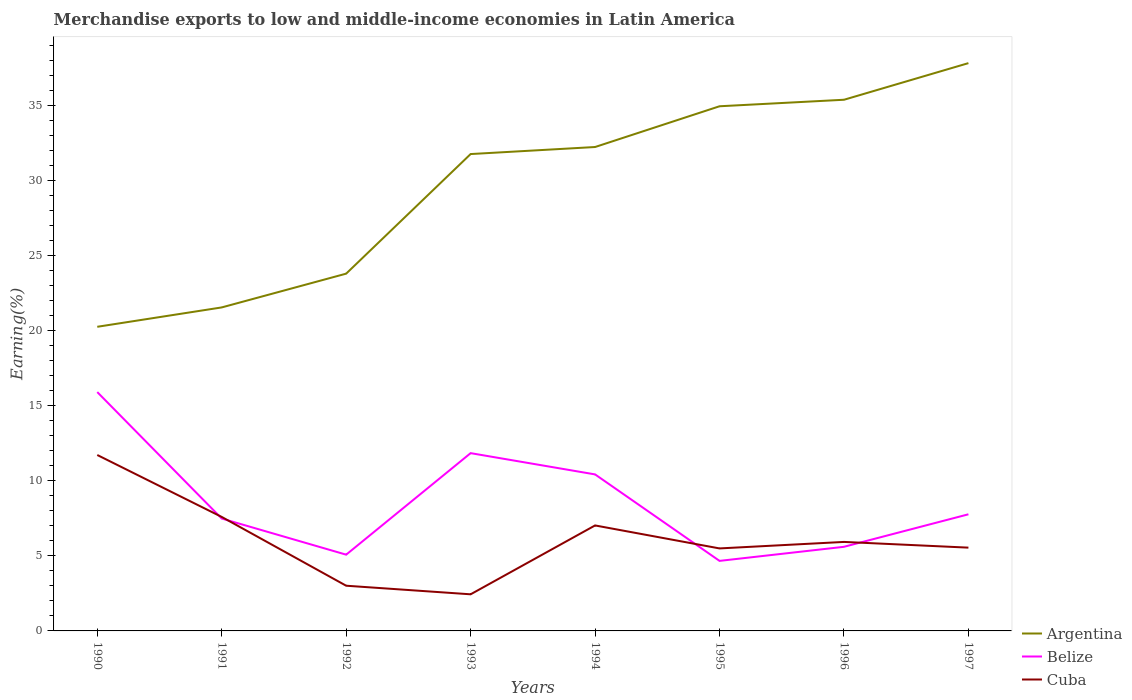Does the line corresponding to Cuba intersect with the line corresponding to Argentina?
Offer a terse response. No. Is the number of lines equal to the number of legend labels?
Give a very brief answer. Yes. Across all years, what is the maximum percentage of amount earned from merchandise exports in Belize?
Ensure brevity in your answer.  4.67. In which year was the percentage of amount earned from merchandise exports in Cuba maximum?
Offer a terse response. 1993. What is the total percentage of amount earned from merchandise exports in Argentina in the graph?
Ensure brevity in your answer.  -13.4. What is the difference between the highest and the second highest percentage of amount earned from merchandise exports in Belize?
Your answer should be very brief. 11.25. How many years are there in the graph?
Your answer should be compact. 8. Does the graph contain grids?
Offer a very short reply. No. How many legend labels are there?
Keep it short and to the point. 3. How are the legend labels stacked?
Provide a short and direct response. Vertical. What is the title of the graph?
Your answer should be compact. Merchandise exports to low and middle-income economies in Latin America. What is the label or title of the X-axis?
Offer a very short reply. Years. What is the label or title of the Y-axis?
Keep it short and to the point. Earning(%). What is the Earning(%) in Argentina in 1990?
Offer a terse response. 20.26. What is the Earning(%) in Belize in 1990?
Offer a terse response. 15.91. What is the Earning(%) in Cuba in 1990?
Give a very brief answer. 11.72. What is the Earning(%) in Argentina in 1991?
Your answer should be very brief. 21.55. What is the Earning(%) in Belize in 1991?
Give a very brief answer. 7.49. What is the Earning(%) in Cuba in 1991?
Your response must be concise. 7.59. What is the Earning(%) of Argentina in 1992?
Your response must be concise. 23.8. What is the Earning(%) in Belize in 1992?
Ensure brevity in your answer.  5.08. What is the Earning(%) in Cuba in 1992?
Your answer should be very brief. 3.01. What is the Earning(%) of Argentina in 1993?
Your response must be concise. 31.77. What is the Earning(%) in Belize in 1993?
Your answer should be very brief. 11.84. What is the Earning(%) in Cuba in 1993?
Make the answer very short. 2.44. What is the Earning(%) in Argentina in 1994?
Give a very brief answer. 32.24. What is the Earning(%) in Belize in 1994?
Provide a succinct answer. 10.43. What is the Earning(%) of Cuba in 1994?
Ensure brevity in your answer.  7.03. What is the Earning(%) of Argentina in 1995?
Provide a short and direct response. 34.96. What is the Earning(%) of Belize in 1995?
Offer a terse response. 4.67. What is the Earning(%) in Cuba in 1995?
Give a very brief answer. 5.5. What is the Earning(%) in Argentina in 1996?
Your answer should be very brief. 35.39. What is the Earning(%) in Belize in 1996?
Make the answer very short. 5.6. What is the Earning(%) of Cuba in 1996?
Make the answer very short. 5.93. What is the Earning(%) of Argentina in 1997?
Provide a succinct answer. 37.83. What is the Earning(%) in Belize in 1997?
Your response must be concise. 7.77. What is the Earning(%) in Cuba in 1997?
Provide a succinct answer. 5.55. Across all years, what is the maximum Earning(%) in Argentina?
Your response must be concise. 37.83. Across all years, what is the maximum Earning(%) of Belize?
Your answer should be very brief. 15.91. Across all years, what is the maximum Earning(%) in Cuba?
Provide a short and direct response. 11.72. Across all years, what is the minimum Earning(%) of Argentina?
Ensure brevity in your answer.  20.26. Across all years, what is the minimum Earning(%) of Belize?
Your answer should be very brief. 4.67. Across all years, what is the minimum Earning(%) of Cuba?
Make the answer very short. 2.44. What is the total Earning(%) of Argentina in the graph?
Make the answer very short. 237.81. What is the total Earning(%) in Belize in the graph?
Offer a terse response. 68.8. What is the total Earning(%) of Cuba in the graph?
Your answer should be very brief. 48.77. What is the difference between the Earning(%) in Argentina in 1990 and that in 1991?
Provide a succinct answer. -1.29. What is the difference between the Earning(%) of Belize in 1990 and that in 1991?
Provide a short and direct response. 8.42. What is the difference between the Earning(%) of Cuba in 1990 and that in 1991?
Make the answer very short. 4.13. What is the difference between the Earning(%) of Argentina in 1990 and that in 1992?
Offer a terse response. -3.54. What is the difference between the Earning(%) of Belize in 1990 and that in 1992?
Offer a very short reply. 10.83. What is the difference between the Earning(%) of Cuba in 1990 and that in 1992?
Offer a very short reply. 8.71. What is the difference between the Earning(%) of Argentina in 1990 and that in 1993?
Make the answer very short. -11.51. What is the difference between the Earning(%) in Belize in 1990 and that in 1993?
Your response must be concise. 4.07. What is the difference between the Earning(%) of Cuba in 1990 and that in 1993?
Offer a terse response. 9.28. What is the difference between the Earning(%) of Argentina in 1990 and that in 1994?
Offer a very short reply. -11.98. What is the difference between the Earning(%) of Belize in 1990 and that in 1994?
Ensure brevity in your answer.  5.48. What is the difference between the Earning(%) in Cuba in 1990 and that in 1994?
Provide a succinct answer. 4.69. What is the difference between the Earning(%) in Argentina in 1990 and that in 1995?
Offer a terse response. -14.69. What is the difference between the Earning(%) in Belize in 1990 and that in 1995?
Your response must be concise. 11.25. What is the difference between the Earning(%) of Cuba in 1990 and that in 1995?
Ensure brevity in your answer.  6.22. What is the difference between the Earning(%) in Argentina in 1990 and that in 1996?
Offer a terse response. -15.13. What is the difference between the Earning(%) in Belize in 1990 and that in 1996?
Offer a very short reply. 10.31. What is the difference between the Earning(%) in Cuba in 1990 and that in 1996?
Keep it short and to the point. 5.79. What is the difference between the Earning(%) of Argentina in 1990 and that in 1997?
Your answer should be compact. -17.57. What is the difference between the Earning(%) in Belize in 1990 and that in 1997?
Make the answer very short. 8.14. What is the difference between the Earning(%) of Cuba in 1990 and that in 1997?
Offer a very short reply. 6.17. What is the difference between the Earning(%) in Argentina in 1991 and that in 1992?
Your answer should be very brief. -2.25. What is the difference between the Earning(%) in Belize in 1991 and that in 1992?
Offer a terse response. 2.41. What is the difference between the Earning(%) of Cuba in 1991 and that in 1992?
Your response must be concise. 4.58. What is the difference between the Earning(%) of Argentina in 1991 and that in 1993?
Make the answer very short. -10.22. What is the difference between the Earning(%) in Belize in 1991 and that in 1993?
Keep it short and to the point. -4.36. What is the difference between the Earning(%) of Cuba in 1991 and that in 1993?
Your answer should be compact. 5.16. What is the difference between the Earning(%) of Argentina in 1991 and that in 1994?
Keep it short and to the point. -10.69. What is the difference between the Earning(%) in Belize in 1991 and that in 1994?
Make the answer very short. -2.94. What is the difference between the Earning(%) in Cuba in 1991 and that in 1994?
Provide a short and direct response. 0.57. What is the difference between the Earning(%) of Argentina in 1991 and that in 1995?
Ensure brevity in your answer.  -13.4. What is the difference between the Earning(%) of Belize in 1991 and that in 1995?
Offer a very short reply. 2.82. What is the difference between the Earning(%) in Cuba in 1991 and that in 1995?
Offer a terse response. 2.1. What is the difference between the Earning(%) of Argentina in 1991 and that in 1996?
Your response must be concise. -13.84. What is the difference between the Earning(%) of Belize in 1991 and that in 1996?
Offer a very short reply. 1.88. What is the difference between the Earning(%) in Cuba in 1991 and that in 1996?
Provide a short and direct response. 1.67. What is the difference between the Earning(%) in Argentina in 1991 and that in 1997?
Make the answer very short. -16.28. What is the difference between the Earning(%) in Belize in 1991 and that in 1997?
Your response must be concise. -0.28. What is the difference between the Earning(%) in Cuba in 1991 and that in 1997?
Your answer should be very brief. 2.05. What is the difference between the Earning(%) in Argentina in 1992 and that in 1993?
Ensure brevity in your answer.  -7.97. What is the difference between the Earning(%) of Belize in 1992 and that in 1993?
Ensure brevity in your answer.  -6.76. What is the difference between the Earning(%) in Cuba in 1992 and that in 1993?
Your answer should be compact. 0.57. What is the difference between the Earning(%) of Argentina in 1992 and that in 1994?
Provide a short and direct response. -8.44. What is the difference between the Earning(%) in Belize in 1992 and that in 1994?
Provide a short and direct response. -5.35. What is the difference between the Earning(%) in Cuba in 1992 and that in 1994?
Keep it short and to the point. -4.02. What is the difference between the Earning(%) in Argentina in 1992 and that in 1995?
Make the answer very short. -11.15. What is the difference between the Earning(%) in Belize in 1992 and that in 1995?
Keep it short and to the point. 0.41. What is the difference between the Earning(%) of Cuba in 1992 and that in 1995?
Ensure brevity in your answer.  -2.49. What is the difference between the Earning(%) of Argentina in 1992 and that in 1996?
Your answer should be compact. -11.59. What is the difference between the Earning(%) in Belize in 1992 and that in 1996?
Provide a short and direct response. -0.52. What is the difference between the Earning(%) of Cuba in 1992 and that in 1996?
Offer a terse response. -2.92. What is the difference between the Earning(%) in Argentina in 1992 and that in 1997?
Make the answer very short. -14.03. What is the difference between the Earning(%) of Belize in 1992 and that in 1997?
Your answer should be very brief. -2.69. What is the difference between the Earning(%) in Cuba in 1992 and that in 1997?
Provide a short and direct response. -2.54. What is the difference between the Earning(%) of Argentina in 1993 and that in 1994?
Your response must be concise. -0.47. What is the difference between the Earning(%) of Belize in 1993 and that in 1994?
Give a very brief answer. 1.42. What is the difference between the Earning(%) of Cuba in 1993 and that in 1994?
Keep it short and to the point. -4.59. What is the difference between the Earning(%) of Argentina in 1993 and that in 1995?
Your response must be concise. -3.18. What is the difference between the Earning(%) in Belize in 1993 and that in 1995?
Keep it short and to the point. 7.18. What is the difference between the Earning(%) of Cuba in 1993 and that in 1995?
Offer a terse response. -3.06. What is the difference between the Earning(%) of Argentina in 1993 and that in 1996?
Offer a terse response. -3.62. What is the difference between the Earning(%) in Belize in 1993 and that in 1996?
Make the answer very short. 6.24. What is the difference between the Earning(%) of Cuba in 1993 and that in 1996?
Your response must be concise. -3.49. What is the difference between the Earning(%) in Argentina in 1993 and that in 1997?
Offer a very short reply. -6.06. What is the difference between the Earning(%) of Belize in 1993 and that in 1997?
Your response must be concise. 4.07. What is the difference between the Earning(%) in Cuba in 1993 and that in 1997?
Make the answer very short. -3.11. What is the difference between the Earning(%) in Argentina in 1994 and that in 1995?
Your answer should be very brief. -2.71. What is the difference between the Earning(%) of Belize in 1994 and that in 1995?
Make the answer very short. 5.76. What is the difference between the Earning(%) of Cuba in 1994 and that in 1995?
Ensure brevity in your answer.  1.53. What is the difference between the Earning(%) in Argentina in 1994 and that in 1996?
Make the answer very short. -3.15. What is the difference between the Earning(%) in Belize in 1994 and that in 1996?
Keep it short and to the point. 4.82. What is the difference between the Earning(%) of Cuba in 1994 and that in 1996?
Keep it short and to the point. 1.1. What is the difference between the Earning(%) of Argentina in 1994 and that in 1997?
Provide a short and direct response. -5.59. What is the difference between the Earning(%) of Belize in 1994 and that in 1997?
Make the answer very short. 2.66. What is the difference between the Earning(%) of Cuba in 1994 and that in 1997?
Provide a succinct answer. 1.48. What is the difference between the Earning(%) in Argentina in 1995 and that in 1996?
Keep it short and to the point. -0.43. What is the difference between the Earning(%) in Belize in 1995 and that in 1996?
Give a very brief answer. -0.94. What is the difference between the Earning(%) of Cuba in 1995 and that in 1996?
Provide a short and direct response. -0.43. What is the difference between the Earning(%) of Argentina in 1995 and that in 1997?
Offer a terse response. -2.87. What is the difference between the Earning(%) in Belize in 1995 and that in 1997?
Make the answer very short. -3.1. What is the difference between the Earning(%) of Cuba in 1995 and that in 1997?
Offer a very short reply. -0.05. What is the difference between the Earning(%) in Argentina in 1996 and that in 1997?
Give a very brief answer. -2.44. What is the difference between the Earning(%) of Belize in 1996 and that in 1997?
Provide a succinct answer. -2.17. What is the difference between the Earning(%) in Cuba in 1996 and that in 1997?
Give a very brief answer. 0.38. What is the difference between the Earning(%) in Argentina in 1990 and the Earning(%) in Belize in 1991?
Offer a terse response. 12.78. What is the difference between the Earning(%) of Argentina in 1990 and the Earning(%) of Cuba in 1991?
Ensure brevity in your answer.  12.67. What is the difference between the Earning(%) of Belize in 1990 and the Earning(%) of Cuba in 1991?
Make the answer very short. 8.32. What is the difference between the Earning(%) of Argentina in 1990 and the Earning(%) of Belize in 1992?
Keep it short and to the point. 15.18. What is the difference between the Earning(%) in Argentina in 1990 and the Earning(%) in Cuba in 1992?
Your response must be concise. 17.25. What is the difference between the Earning(%) in Belize in 1990 and the Earning(%) in Cuba in 1992?
Ensure brevity in your answer.  12.9. What is the difference between the Earning(%) of Argentina in 1990 and the Earning(%) of Belize in 1993?
Offer a terse response. 8.42. What is the difference between the Earning(%) in Argentina in 1990 and the Earning(%) in Cuba in 1993?
Give a very brief answer. 17.82. What is the difference between the Earning(%) in Belize in 1990 and the Earning(%) in Cuba in 1993?
Your answer should be very brief. 13.47. What is the difference between the Earning(%) of Argentina in 1990 and the Earning(%) of Belize in 1994?
Ensure brevity in your answer.  9.84. What is the difference between the Earning(%) in Argentina in 1990 and the Earning(%) in Cuba in 1994?
Your response must be concise. 13.24. What is the difference between the Earning(%) in Belize in 1990 and the Earning(%) in Cuba in 1994?
Your answer should be compact. 8.88. What is the difference between the Earning(%) of Argentina in 1990 and the Earning(%) of Belize in 1995?
Offer a very short reply. 15.6. What is the difference between the Earning(%) of Argentina in 1990 and the Earning(%) of Cuba in 1995?
Make the answer very short. 14.77. What is the difference between the Earning(%) in Belize in 1990 and the Earning(%) in Cuba in 1995?
Offer a terse response. 10.42. What is the difference between the Earning(%) in Argentina in 1990 and the Earning(%) in Belize in 1996?
Your answer should be compact. 14.66. What is the difference between the Earning(%) in Argentina in 1990 and the Earning(%) in Cuba in 1996?
Make the answer very short. 14.33. What is the difference between the Earning(%) of Belize in 1990 and the Earning(%) of Cuba in 1996?
Make the answer very short. 9.98. What is the difference between the Earning(%) in Argentina in 1990 and the Earning(%) in Belize in 1997?
Keep it short and to the point. 12.49. What is the difference between the Earning(%) of Argentina in 1990 and the Earning(%) of Cuba in 1997?
Your response must be concise. 14.71. What is the difference between the Earning(%) in Belize in 1990 and the Earning(%) in Cuba in 1997?
Your answer should be compact. 10.36. What is the difference between the Earning(%) of Argentina in 1991 and the Earning(%) of Belize in 1992?
Give a very brief answer. 16.47. What is the difference between the Earning(%) in Argentina in 1991 and the Earning(%) in Cuba in 1992?
Your answer should be compact. 18.54. What is the difference between the Earning(%) in Belize in 1991 and the Earning(%) in Cuba in 1992?
Offer a very short reply. 4.48. What is the difference between the Earning(%) of Argentina in 1991 and the Earning(%) of Belize in 1993?
Offer a very short reply. 9.71. What is the difference between the Earning(%) in Argentina in 1991 and the Earning(%) in Cuba in 1993?
Your answer should be compact. 19.11. What is the difference between the Earning(%) of Belize in 1991 and the Earning(%) of Cuba in 1993?
Give a very brief answer. 5.05. What is the difference between the Earning(%) in Argentina in 1991 and the Earning(%) in Belize in 1994?
Offer a terse response. 11.13. What is the difference between the Earning(%) in Argentina in 1991 and the Earning(%) in Cuba in 1994?
Give a very brief answer. 14.53. What is the difference between the Earning(%) of Belize in 1991 and the Earning(%) of Cuba in 1994?
Keep it short and to the point. 0.46. What is the difference between the Earning(%) of Argentina in 1991 and the Earning(%) of Belize in 1995?
Provide a succinct answer. 16.89. What is the difference between the Earning(%) in Argentina in 1991 and the Earning(%) in Cuba in 1995?
Offer a very short reply. 16.06. What is the difference between the Earning(%) of Belize in 1991 and the Earning(%) of Cuba in 1995?
Your answer should be very brief. 1.99. What is the difference between the Earning(%) of Argentina in 1991 and the Earning(%) of Belize in 1996?
Provide a succinct answer. 15.95. What is the difference between the Earning(%) of Argentina in 1991 and the Earning(%) of Cuba in 1996?
Give a very brief answer. 15.62. What is the difference between the Earning(%) of Belize in 1991 and the Earning(%) of Cuba in 1996?
Provide a short and direct response. 1.56. What is the difference between the Earning(%) of Argentina in 1991 and the Earning(%) of Belize in 1997?
Make the answer very short. 13.78. What is the difference between the Earning(%) in Argentina in 1991 and the Earning(%) in Cuba in 1997?
Provide a succinct answer. 16. What is the difference between the Earning(%) of Belize in 1991 and the Earning(%) of Cuba in 1997?
Your answer should be compact. 1.94. What is the difference between the Earning(%) in Argentina in 1992 and the Earning(%) in Belize in 1993?
Offer a very short reply. 11.96. What is the difference between the Earning(%) of Argentina in 1992 and the Earning(%) of Cuba in 1993?
Provide a short and direct response. 21.36. What is the difference between the Earning(%) of Belize in 1992 and the Earning(%) of Cuba in 1993?
Offer a very short reply. 2.64. What is the difference between the Earning(%) in Argentina in 1992 and the Earning(%) in Belize in 1994?
Keep it short and to the point. 13.38. What is the difference between the Earning(%) in Argentina in 1992 and the Earning(%) in Cuba in 1994?
Provide a succinct answer. 16.78. What is the difference between the Earning(%) of Belize in 1992 and the Earning(%) of Cuba in 1994?
Offer a very short reply. -1.95. What is the difference between the Earning(%) in Argentina in 1992 and the Earning(%) in Belize in 1995?
Provide a succinct answer. 19.14. What is the difference between the Earning(%) of Argentina in 1992 and the Earning(%) of Cuba in 1995?
Your answer should be very brief. 18.31. What is the difference between the Earning(%) in Belize in 1992 and the Earning(%) in Cuba in 1995?
Make the answer very short. -0.42. What is the difference between the Earning(%) in Argentina in 1992 and the Earning(%) in Belize in 1996?
Make the answer very short. 18.2. What is the difference between the Earning(%) of Argentina in 1992 and the Earning(%) of Cuba in 1996?
Make the answer very short. 17.87. What is the difference between the Earning(%) in Belize in 1992 and the Earning(%) in Cuba in 1996?
Keep it short and to the point. -0.85. What is the difference between the Earning(%) of Argentina in 1992 and the Earning(%) of Belize in 1997?
Make the answer very short. 16.03. What is the difference between the Earning(%) of Argentina in 1992 and the Earning(%) of Cuba in 1997?
Make the answer very short. 18.26. What is the difference between the Earning(%) of Belize in 1992 and the Earning(%) of Cuba in 1997?
Your response must be concise. -0.47. What is the difference between the Earning(%) of Argentina in 1993 and the Earning(%) of Belize in 1994?
Offer a terse response. 21.34. What is the difference between the Earning(%) in Argentina in 1993 and the Earning(%) in Cuba in 1994?
Ensure brevity in your answer.  24.74. What is the difference between the Earning(%) of Belize in 1993 and the Earning(%) of Cuba in 1994?
Offer a very short reply. 4.82. What is the difference between the Earning(%) of Argentina in 1993 and the Earning(%) of Belize in 1995?
Provide a succinct answer. 27.1. What is the difference between the Earning(%) of Argentina in 1993 and the Earning(%) of Cuba in 1995?
Give a very brief answer. 26.27. What is the difference between the Earning(%) of Belize in 1993 and the Earning(%) of Cuba in 1995?
Ensure brevity in your answer.  6.35. What is the difference between the Earning(%) in Argentina in 1993 and the Earning(%) in Belize in 1996?
Keep it short and to the point. 26.17. What is the difference between the Earning(%) of Argentina in 1993 and the Earning(%) of Cuba in 1996?
Keep it short and to the point. 25.84. What is the difference between the Earning(%) of Belize in 1993 and the Earning(%) of Cuba in 1996?
Offer a terse response. 5.91. What is the difference between the Earning(%) of Argentina in 1993 and the Earning(%) of Belize in 1997?
Offer a terse response. 24. What is the difference between the Earning(%) in Argentina in 1993 and the Earning(%) in Cuba in 1997?
Your answer should be compact. 26.22. What is the difference between the Earning(%) in Belize in 1993 and the Earning(%) in Cuba in 1997?
Your answer should be compact. 6.3. What is the difference between the Earning(%) in Argentina in 1994 and the Earning(%) in Belize in 1995?
Offer a terse response. 27.57. What is the difference between the Earning(%) in Argentina in 1994 and the Earning(%) in Cuba in 1995?
Your answer should be compact. 26.74. What is the difference between the Earning(%) in Belize in 1994 and the Earning(%) in Cuba in 1995?
Offer a very short reply. 4.93. What is the difference between the Earning(%) in Argentina in 1994 and the Earning(%) in Belize in 1996?
Provide a short and direct response. 26.64. What is the difference between the Earning(%) in Argentina in 1994 and the Earning(%) in Cuba in 1996?
Provide a succinct answer. 26.31. What is the difference between the Earning(%) of Belize in 1994 and the Earning(%) of Cuba in 1996?
Your answer should be very brief. 4.5. What is the difference between the Earning(%) of Argentina in 1994 and the Earning(%) of Belize in 1997?
Keep it short and to the point. 24.47. What is the difference between the Earning(%) of Argentina in 1994 and the Earning(%) of Cuba in 1997?
Keep it short and to the point. 26.69. What is the difference between the Earning(%) of Belize in 1994 and the Earning(%) of Cuba in 1997?
Offer a terse response. 4.88. What is the difference between the Earning(%) in Argentina in 1995 and the Earning(%) in Belize in 1996?
Your answer should be compact. 29.35. What is the difference between the Earning(%) of Argentina in 1995 and the Earning(%) of Cuba in 1996?
Your answer should be very brief. 29.03. What is the difference between the Earning(%) in Belize in 1995 and the Earning(%) in Cuba in 1996?
Your answer should be very brief. -1.26. What is the difference between the Earning(%) of Argentina in 1995 and the Earning(%) of Belize in 1997?
Ensure brevity in your answer.  27.19. What is the difference between the Earning(%) of Argentina in 1995 and the Earning(%) of Cuba in 1997?
Keep it short and to the point. 29.41. What is the difference between the Earning(%) in Belize in 1995 and the Earning(%) in Cuba in 1997?
Your answer should be compact. -0.88. What is the difference between the Earning(%) in Argentina in 1996 and the Earning(%) in Belize in 1997?
Make the answer very short. 27.62. What is the difference between the Earning(%) in Argentina in 1996 and the Earning(%) in Cuba in 1997?
Provide a succinct answer. 29.84. What is the difference between the Earning(%) in Belize in 1996 and the Earning(%) in Cuba in 1997?
Offer a very short reply. 0.06. What is the average Earning(%) in Argentina per year?
Offer a very short reply. 29.73. What is the average Earning(%) in Belize per year?
Provide a short and direct response. 8.6. What is the average Earning(%) of Cuba per year?
Provide a succinct answer. 6.1. In the year 1990, what is the difference between the Earning(%) in Argentina and Earning(%) in Belize?
Keep it short and to the point. 4.35. In the year 1990, what is the difference between the Earning(%) of Argentina and Earning(%) of Cuba?
Make the answer very short. 8.54. In the year 1990, what is the difference between the Earning(%) of Belize and Earning(%) of Cuba?
Your response must be concise. 4.19. In the year 1991, what is the difference between the Earning(%) of Argentina and Earning(%) of Belize?
Make the answer very short. 14.07. In the year 1991, what is the difference between the Earning(%) of Argentina and Earning(%) of Cuba?
Provide a succinct answer. 13.96. In the year 1991, what is the difference between the Earning(%) in Belize and Earning(%) in Cuba?
Offer a very short reply. -0.11. In the year 1992, what is the difference between the Earning(%) in Argentina and Earning(%) in Belize?
Keep it short and to the point. 18.72. In the year 1992, what is the difference between the Earning(%) of Argentina and Earning(%) of Cuba?
Keep it short and to the point. 20.79. In the year 1992, what is the difference between the Earning(%) in Belize and Earning(%) in Cuba?
Provide a short and direct response. 2.07. In the year 1993, what is the difference between the Earning(%) in Argentina and Earning(%) in Belize?
Keep it short and to the point. 19.93. In the year 1993, what is the difference between the Earning(%) of Argentina and Earning(%) of Cuba?
Your response must be concise. 29.33. In the year 1993, what is the difference between the Earning(%) of Belize and Earning(%) of Cuba?
Ensure brevity in your answer.  9.4. In the year 1994, what is the difference between the Earning(%) in Argentina and Earning(%) in Belize?
Provide a short and direct response. 21.81. In the year 1994, what is the difference between the Earning(%) in Argentina and Earning(%) in Cuba?
Ensure brevity in your answer.  25.21. In the year 1994, what is the difference between the Earning(%) of Belize and Earning(%) of Cuba?
Provide a short and direct response. 3.4. In the year 1995, what is the difference between the Earning(%) of Argentina and Earning(%) of Belize?
Your answer should be compact. 30.29. In the year 1995, what is the difference between the Earning(%) of Argentina and Earning(%) of Cuba?
Make the answer very short. 29.46. In the year 1995, what is the difference between the Earning(%) of Belize and Earning(%) of Cuba?
Your answer should be very brief. -0.83. In the year 1996, what is the difference between the Earning(%) in Argentina and Earning(%) in Belize?
Your answer should be very brief. 29.79. In the year 1996, what is the difference between the Earning(%) in Argentina and Earning(%) in Cuba?
Provide a succinct answer. 29.46. In the year 1996, what is the difference between the Earning(%) in Belize and Earning(%) in Cuba?
Your answer should be compact. -0.33. In the year 1997, what is the difference between the Earning(%) of Argentina and Earning(%) of Belize?
Provide a short and direct response. 30.06. In the year 1997, what is the difference between the Earning(%) of Argentina and Earning(%) of Cuba?
Give a very brief answer. 32.28. In the year 1997, what is the difference between the Earning(%) of Belize and Earning(%) of Cuba?
Your response must be concise. 2.22. What is the ratio of the Earning(%) of Argentina in 1990 to that in 1991?
Make the answer very short. 0.94. What is the ratio of the Earning(%) of Belize in 1990 to that in 1991?
Give a very brief answer. 2.13. What is the ratio of the Earning(%) of Cuba in 1990 to that in 1991?
Give a very brief answer. 1.54. What is the ratio of the Earning(%) of Argentina in 1990 to that in 1992?
Offer a terse response. 0.85. What is the ratio of the Earning(%) in Belize in 1990 to that in 1992?
Your answer should be compact. 3.13. What is the ratio of the Earning(%) of Cuba in 1990 to that in 1992?
Provide a short and direct response. 3.89. What is the ratio of the Earning(%) of Argentina in 1990 to that in 1993?
Keep it short and to the point. 0.64. What is the ratio of the Earning(%) of Belize in 1990 to that in 1993?
Keep it short and to the point. 1.34. What is the ratio of the Earning(%) in Cuba in 1990 to that in 1993?
Offer a terse response. 4.8. What is the ratio of the Earning(%) of Argentina in 1990 to that in 1994?
Provide a short and direct response. 0.63. What is the ratio of the Earning(%) of Belize in 1990 to that in 1994?
Ensure brevity in your answer.  1.53. What is the ratio of the Earning(%) in Cuba in 1990 to that in 1994?
Keep it short and to the point. 1.67. What is the ratio of the Earning(%) of Argentina in 1990 to that in 1995?
Provide a short and direct response. 0.58. What is the ratio of the Earning(%) in Belize in 1990 to that in 1995?
Offer a very short reply. 3.41. What is the ratio of the Earning(%) of Cuba in 1990 to that in 1995?
Provide a succinct answer. 2.13. What is the ratio of the Earning(%) of Argentina in 1990 to that in 1996?
Make the answer very short. 0.57. What is the ratio of the Earning(%) of Belize in 1990 to that in 1996?
Offer a terse response. 2.84. What is the ratio of the Earning(%) of Cuba in 1990 to that in 1996?
Provide a short and direct response. 1.98. What is the ratio of the Earning(%) in Argentina in 1990 to that in 1997?
Offer a terse response. 0.54. What is the ratio of the Earning(%) in Belize in 1990 to that in 1997?
Provide a succinct answer. 2.05. What is the ratio of the Earning(%) of Cuba in 1990 to that in 1997?
Offer a terse response. 2.11. What is the ratio of the Earning(%) in Argentina in 1991 to that in 1992?
Keep it short and to the point. 0.91. What is the ratio of the Earning(%) in Belize in 1991 to that in 1992?
Your answer should be compact. 1.47. What is the ratio of the Earning(%) of Cuba in 1991 to that in 1992?
Provide a short and direct response. 2.52. What is the ratio of the Earning(%) of Argentina in 1991 to that in 1993?
Your response must be concise. 0.68. What is the ratio of the Earning(%) in Belize in 1991 to that in 1993?
Keep it short and to the point. 0.63. What is the ratio of the Earning(%) in Cuba in 1991 to that in 1993?
Offer a terse response. 3.11. What is the ratio of the Earning(%) in Argentina in 1991 to that in 1994?
Offer a very short reply. 0.67. What is the ratio of the Earning(%) in Belize in 1991 to that in 1994?
Offer a very short reply. 0.72. What is the ratio of the Earning(%) of Cuba in 1991 to that in 1994?
Offer a very short reply. 1.08. What is the ratio of the Earning(%) of Argentina in 1991 to that in 1995?
Give a very brief answer. 0.62. What is the ratio of the Earning(%) in Belize in 1991 to that in 1995?
Ensure brevity in your answer.  1.6. What is the ratio of the Earning(%) of Cuba in 1991 to that in 1995?
Offer a very short reply. 1.38. What is the ratio of the Earning(%) in Argentina in 1991 to that in 1996?
Provide a succinct answer. 0.61. What is the ratio of the Earning(%) of Belize in 1991 to that in 1996?
Offer a terse response. 1.34. What is the ratio of the Earning(%) of Cuba in 1991 to that in 1996?
Keep it short and to the point. 1.28. What is the ratio of the Earning(%) in Argentina in 1991 to that in 1997?
Offer a terse response. 0.57. What is the ratio of the Earning(%) in Belize in 1991 to that in 1997?
Make the answer very short. 0.96. What is the ratio of the Earning(%) of Cuba in 1991 to that in 1997?
Give a very brief answer. 1.37. What is the ratio of the Earning(%) in Argentina in 1992 to that in 1993?
Provide a short and direct response. 0.75. What is the ratio of the Earning(%) in Belize in 1992 to that in 1993?
Give a very brief answer. 0.43. What is the ratio of the Earning(%) in Cuba in 1992 to that in 1993?
Provide a succinct answer. 1.23. What is the ratio of the Earning(%) in Argentina in 1992 to that in 1994?
Keep it short and to the point. 0.74. What is the ratio of the Earning(%) of Belize in 1992 to that in 1994?
Offer a very short reply. 0.49. What is the ratio of the Earning(%) of Cuba in 1992 to that in 1994?
Ensure brevity in your answer.  0.43. What is the ratio of the Earning(%) of Argentina in 1992 to that in 1995?
Your answer should be compact. 0.68. What is the ratio of the Earning(%) of Belize in 1992 to that in 1995?
Your answer should be compact. 1.09. What is the ratio of the Earning(%) of Cuba in 1992 to that in 1995?
Provide a succinct answer. 0.55. What is the ratio of the Earning(%) of Argentina in 1992 to that in 1996?
Your answer should be very brief. 0.67. What is the ratio of the Earning(%) in Belize in 1992 to that in 1996?
Give a very brief answer. 0.91. What is the ratio of the Earning(%) in Cuba in 1992 to that in 1996?
Keep it short and to the point. 0.51. What is the ratio of the Earning(%) in Argentina in 1992 to that in 1997?
Your answer should be very brief. 0.63. What is the ratio of the Earning(%) in Belize in 1992 to that in 1997?
Ensure brevity in your answer.  0.65. What is the ratio of the Earning(%) of Cuba in 1992 to that in 1997?
Ensure brevity in your answer.  0.54. What is the ratio of the Earning(%) in Argentina in 1993 to that in 1994?
Your response must be concise. 0.99. What is the ratio of the Earning(%) of Belize in 1993 to that in 1994?
Offer a very short reply. 1.14. What is the ratio of the Earning(%) of Cuba in 1993 to that in 1994?
Provide a short and direct response. 0.35. What is the ratio of the Earning(%) of Argentina in 1993 to that in 1995?
Offer a very short reply. 0.91. What is the ratio of the Earning(%) of Belize in 1993 to that in 1995?
Keep it short and to the point. 2.54. What is the ratio of the Earning(%) in Cuba in 1993 to that in 1995?
Keep it short and to the point. 0.44. What is the ratio of the Earning(%) in Argentina in 1993 to that in 1996?
Give a very brief answer. 0.9. What is the ratio of the Earning(%) of Belize in 1993 to that in 1996?
Your answer should be compact. 2.11. What is the ratio of the Earning(%) of Cuba in 1993 to that in 1996?
Ensure brevity in your answer.  0.41. What is the ratio of the Earning(%) in Argentina in 1993 to that in 1997?
Your answer should be compact. 0.84. What is the ratio of the Earning(%) of Belize in 1993 to that in 1997?
Keep it short and to the point. 1.52. What is the ratio of the Earning(%) of Cuba in 1993 to that in 1997?
Your response must be concise. 0.44. What is the ratio of the Earning(%) of Argentina in 1994 to that in 1995?
Keep it short and to the point. 0.92. What is the ratio of the Earning(%) of Belize in 1994 to that in 1995?
Your response must be concise. 2.23. What is the ratio of the Earning(%) of Cuba in 1994 to that in 1995?
Provide a succinct answer. 1.28. What is the ratio of the Earning(%) of Argentina in 1994 to that in 1996?
Ensure brevity in your answer.  0.91. What is the ratio of the Earning(%) in Belize in 1994 to that in 1996?
Provide a short and direct response. 1.86. What is the ratio of the Earning(%) in Cuba in 1994 to that in 1996?
Provide a succinct answer. 1.19. What is the ratio of the Earning(%) of Argentina in 1994 to that in 1997?
Your response must be concise. 0.85. What is the ratio of the Earning(%) of Belize in 1994 to that in 1997?
Keep it short and to the point. 1.34. What is the ratio of the Earning(%) in Cuba in 1994 to that in 1997?
Offer a terse response. 1.27. What is the ratio of the Earning(%) of Belize in 1995 to that in 1996?
Your answer should be compact. 0.83. What is the ratio of the Earning(%) of Cuba in 1995 to that in 1996?
Your response must be concise. 0.93. What is the ratio of the Earning(%) in Argentina in 1995 to that in 1997?
Your answer should be very brief. 0.92. What is the ratio of the Earning(%) of Belize in 1995 to that in 1997?
Ensure brevity in your answer.  0.6. What is the ratio of the Earning(%) in Cuba in 1995 to that in 1997?
Give a very brief answer. 0.99. What is the ratio of the Earning(%) in Argentina in 1996 to that in 1997?
Make the answer very short. 0.94. What is the ratio of the Earning(%) of Belize in 1996 to that in 1997?
Offer a very short reply. 0.72. What is the ratio of the Earning(%) of Cuba in 1996 to that in 1997?
Provide a succinct answer. 1.07. What is the difference between the highest and the second highest Earning(%) of Argentina?
Your response must be concise. 2.44. What is the difference between the highest and the second highest Earning(%) in Belize?
Your answer should be compact. 4.07. What is the difference between the highest and the second highest Earning(%) in Cuba?
Offer a very short reply. 4.13. What is the difference between the highest and the lowest Earning(%) of Argentina?
Make the answer very short. 17.57. What is the difference between the highest and the lowest Earning(%) in Belize?
Your answer should be compact. 11.25. What is the difference between the highest and the lowest Earning(%) in Cuba?
Make the answer very short. 9.28. 